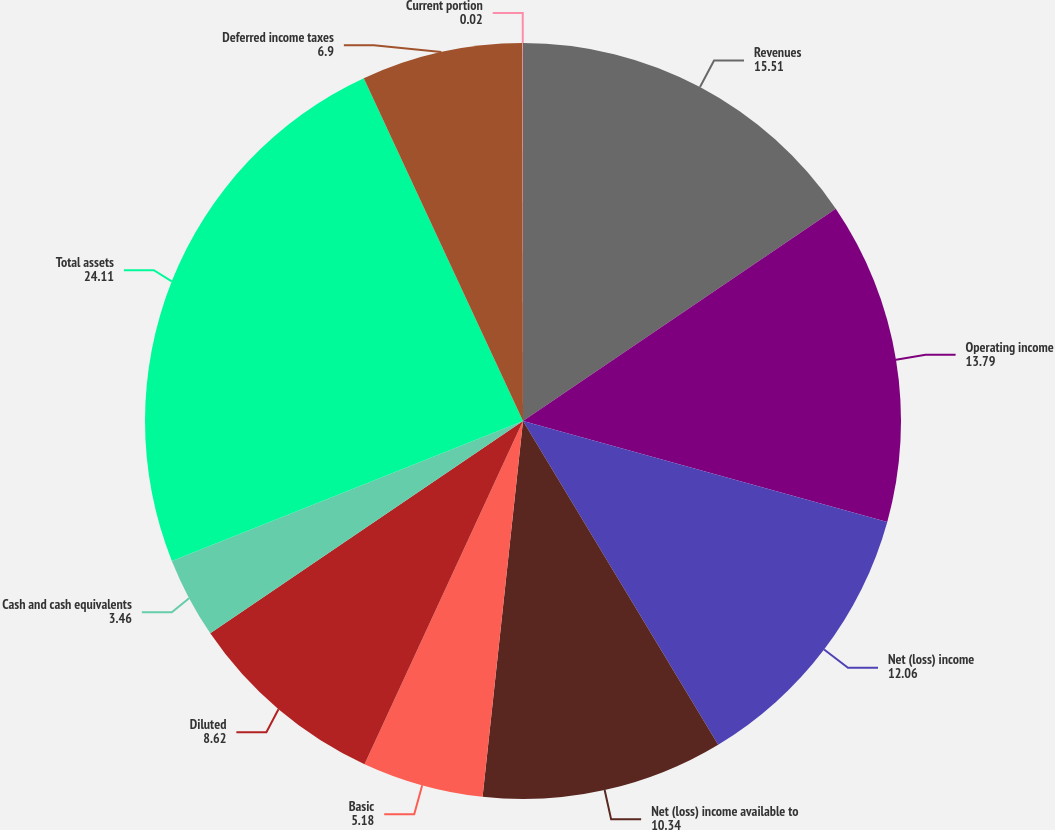Convert chart to OTSL. <chart><loc_0><loc_0><loc_500><loc_500><pie_chart><fcel>Revenues<fcel>Operating income<fcel>Net (loss) income<fcel>Net (loss) income available to<fcel>Basic<fcel>Diluted<fcel>Cash and cash equivalents<fcel>Total assets<fcel>Deferred income taxes<fcel>Current portion<nl><fcel>15.51%<fcel>13.79%<fcel>12.06%<fcel>10.34%<fcel>5.18%<fcel>8.62%<fcel>3.46%<fcel>24.11%<fcel>6.9%<fcel>0.02%<nl></chart> 